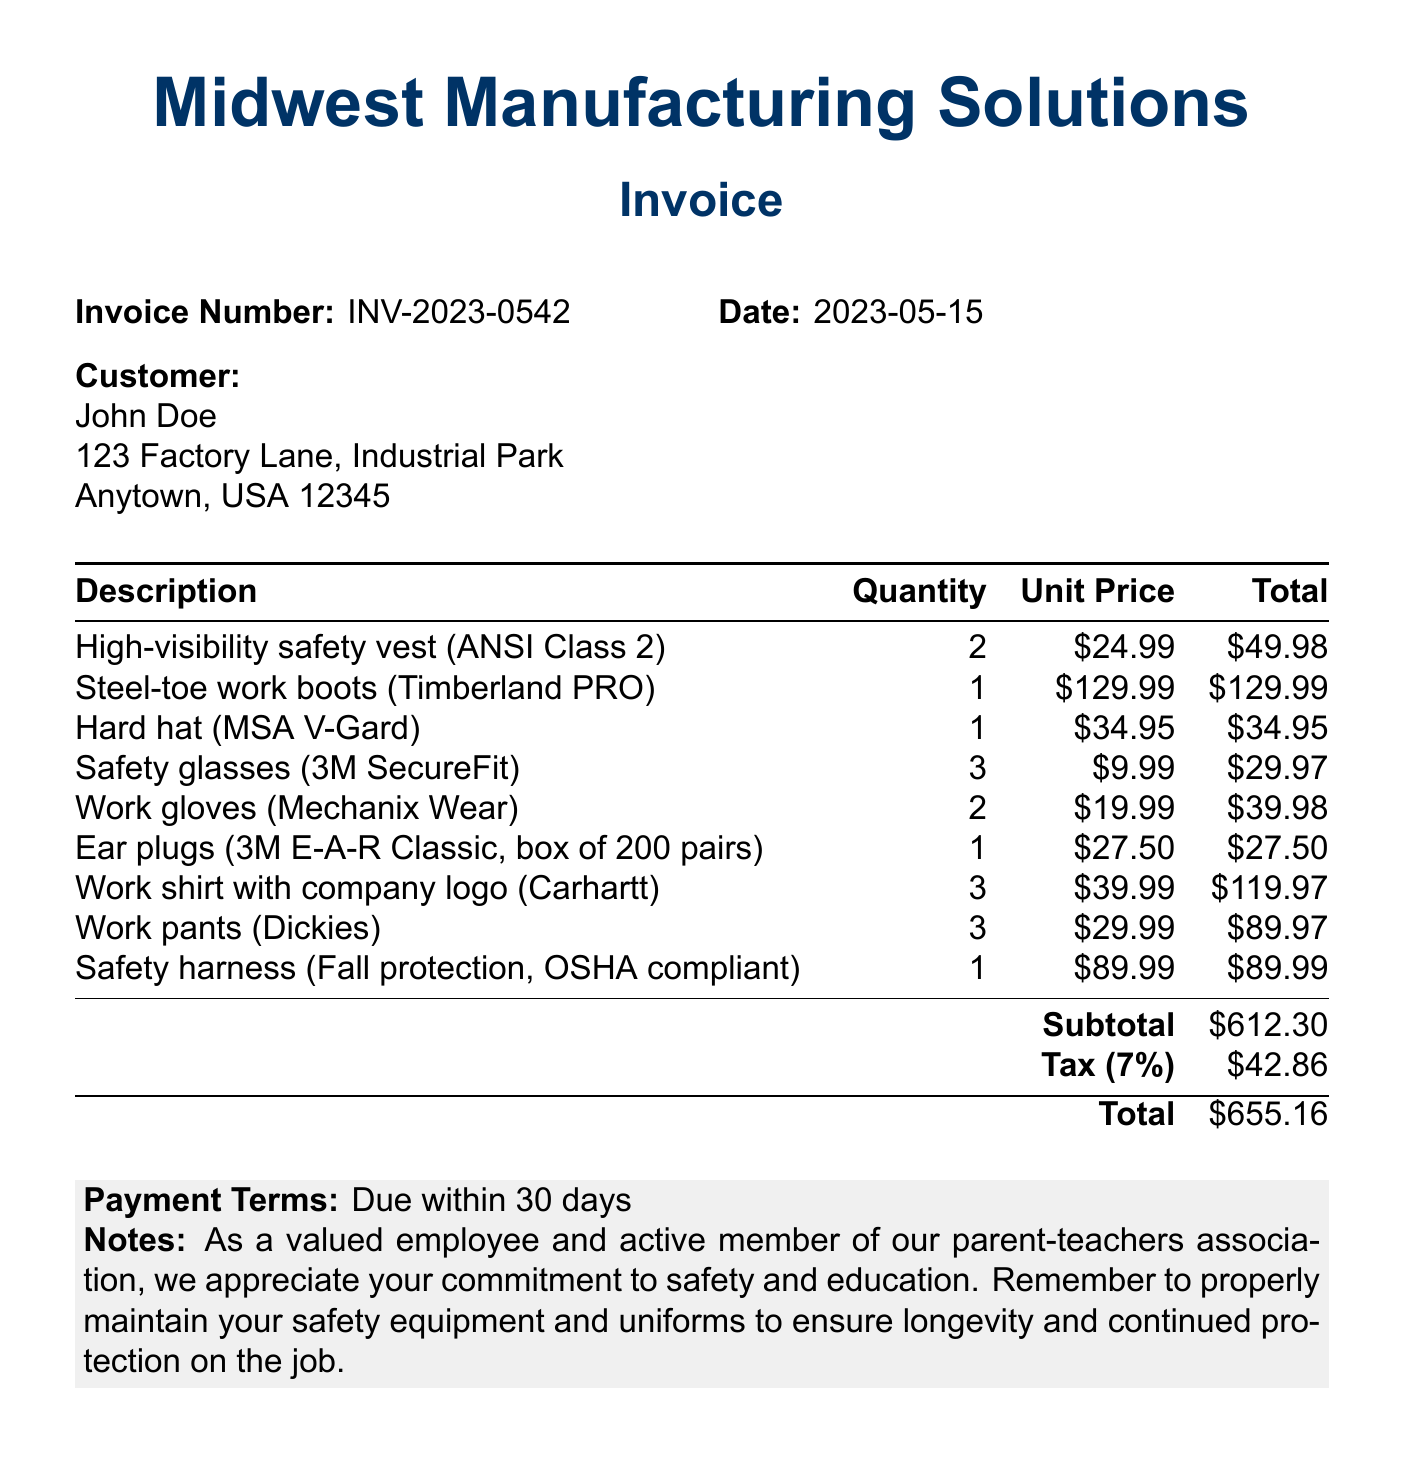What is the company name? The company name is listed at the top of the invoice.
Answer: Midwest Manufacturing Solutions What is the invoice number? The invoice number is provided in the header section of the document.
Answer: INV-2023-0542 What is the date of the invoice? The date of the invoice is specified in the header details.
Answer: 2023-05-15 What is the total amount due? The total amount is calculated at the bottom of the invoice, including subtotal and tax.
Answer: $655.16 How many high-visibility safety vests were ordered? The quantity of high-visibility safety vests is detailed in the itemized list.
Answer: 2 What is the subtotal amount before tax? The subtotal amount is identified in the invoice just before the tax is calculated.
Answer: $612.30 What payment terms are mentioned? The payment terms are indicated in the notes section of the invoice.
Answer: Due within 30 days What specific item has a quantity of three ordered? The invoice lists multiple items, and one of them is specified with a quantity of three.
Answer: Work shirt with company logo (Carhartt) What is highlighted in the notes section of the invoice? The notes section contains appreciation for the customer and maintenance advice.
Answer: Commitment to safety and education 